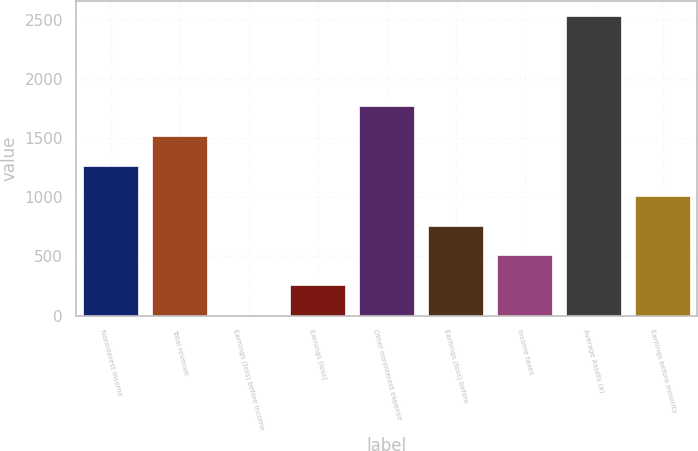<chart> <loc_0><loc_0><loc_500><loc_500><bar_chart><fcel>Noninterest income<fcel>Total revenue<fcel>Earnings (loss) before income<fcel>Earnings (loss)<fcel>Other noninterest expense<fcel>Earnings (loss) before<fcel>Income taxes<fcel>Average Assets (a)<fcel>Earnings before minority<nl><fcel>1268.5<fcel>1522<fcel>1<fcel>254.5<fcel>1775.5<fcel>761.5<fcel>508<fcel>2536<fcel>1015<nl></chart> 